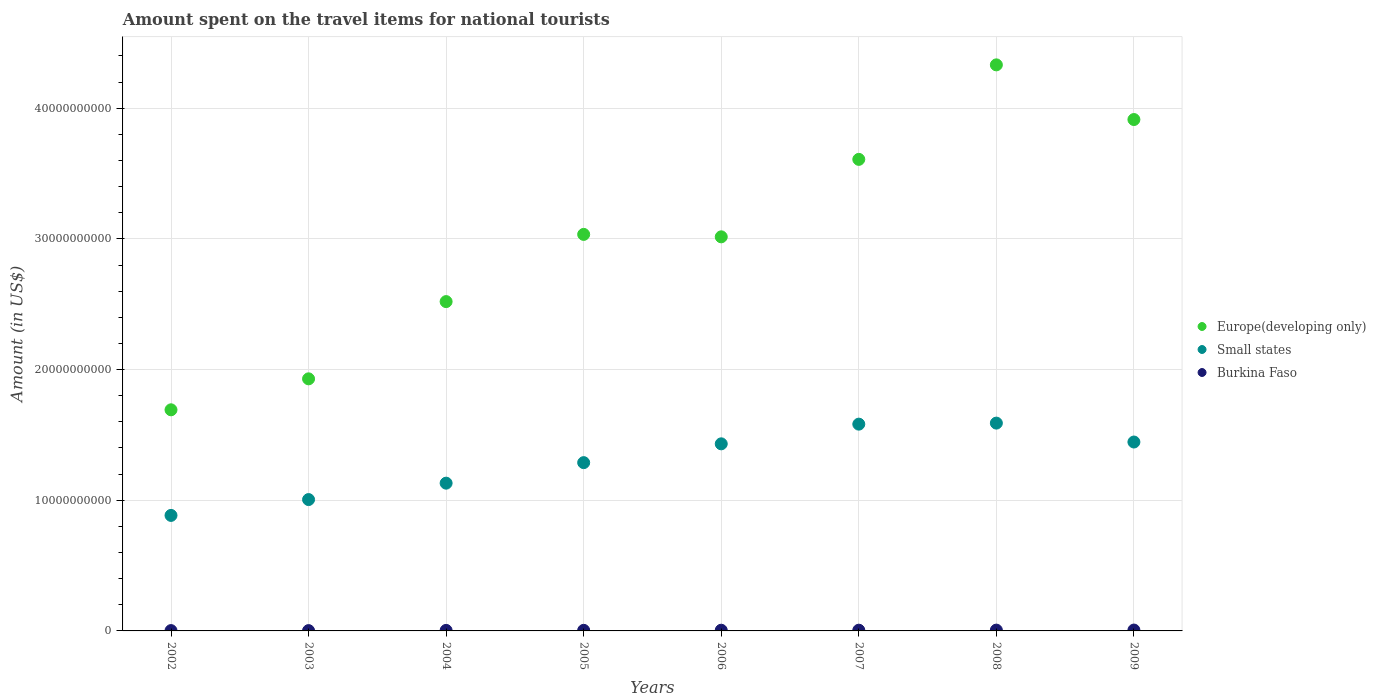How many different coloured dotlines are there?
Your answer should be compact. 3. Is the number of dotlines equal to the number of legend labels?
Offer a terse response. Yes. What is the amount spent on the travel items for national tourists in Europe(developing only) in 2003?
Provide a short and direct response. 1.93e+1. Across all years, what is the maximum amount spent on the travel items for national tourists in Burkina Faso?
Make the answer very short. 6.60e+07. Across all years, what is the minimum amount spent on the travel items for national tourists in Burkina Faso?
Give a very brief answer. 2.40e+07. What is the total amount spent on the travel items for national tourists in Europe(developing only) in the graph?
Your answer should be compact. 2.40e+11. What is the difference between the amount spent on the travel items for national tourists in Burkina Faso in 2006 and that in 2008?
Make the answer very short. -9.00e+06. What is the difference between the amount spent on the travel items for national tourists in Burkina Faso in 2007 and the amount spent on the travel items for national tourists in Europe(developing only) in 2009?
Your response must be concise. -3.91e+1. What is the average amount spent on the travel items for national tourists in Burkina Faso per year?
Keep it short and to the point. 4.64e+07. In the year 2005, what is the difference between the amount spent on the travel items for national tourists in Small states and amount spent on the travel items for national tourists in Burkina Faso?
Make the answer very short. 1.28e+1. What is the ratio of the amount spent on the travel items for national tourists in Burkina Faso in 2005 to that in 2007?
Ensure brevity in your answer.  0.8. Is the amount spent on the travel items for national tourists in Europe(developing only) in 2003 less than that in 2005?
Offer a very short reply. Yes. What is the difference between the highest and the second highest amount spent on the travel items for national tourists in Europe(developing only)?
Make the answer very short. 4.18e+09. What is the difference between the highest and the lowest amount spent on the travel items for national tourists in Small states?
Make the answer very short. 7.06e+09. Is it the case that in every year, the sum of the amount spent on the travel items for national tourists in Small states and amount spent on the travel items for national tourists in Europe(developing only)  is greater than the amount spent on the travel items for national tourists in Burkina Faso?
Ensure brevity in your answer.  Yes. Is the amount spent on the travel items for national tourists in Europe(developing only) strictly greater than the amount spent on the travel items for national tourists in Small states over the years?
Offer a very short reply. Yes. Is the amount spent on the travel items for national tourists in Small states strictly less than the amount spent on the travel items for national tourists in Burkina Faso over the years?
Your response must be concise. No. How many dotlines are there?
Keep it short and to the point. 3. How many years are there in the graph?
Your answer should be very brief. 8. Are the values on the major ticks of Y-axis written in scientific E-notation?
Give a very brief answer. No. Does the graph contain any zero values?
Make the answer very short. No. What is the title of the graph?
Provide a succinct answer. Amount spent on the travel items for national tourists. Does "Tanzania" appear as one of the legend labels in the graph?
Your answer should be compact. No. What is the Amount (in US$) of Europe(developing only) in 2002?
Offer a very short reply. 1.69e+1. What is the Amount (in US$) in Small states in 2002?
Your response must be concise. 8.84e+09. What is the Amount (in US$) of Burkina Faso in 2002?
Provide a short and direct response. 2.50e+07. What is the Amount (in US$) of Europe(developing only) in 2003?
Keep it short and to the point. 1.93e+1. What is the Amount (in US$) of Small states in 2003?
Offer a terse response. 1.01e+1. What is the Amount (in US$) of Burkina Faso in 2003?
Offer a very short reply. 2.40e+07. What is the Amount (in US$) of Europe(developing only) in 2004?
Your answer should be very brief. 2.52e+1. What is the Amount (in US$) of Small states in 2004?
Ensure brevity in your answer.  1.13e+1. What is the Amount (in US$) of Burkina Faso in 2004?
Your answer should be very brief. 4.00e+07. What is the Amount (in US$) of Europe(developing only) in 2005?
Give a very brief answer. 3.03e+1. What is the Amount (in US$) of Small states in 2005?
Your response must be concise. 1.29e+1. What is the Amount (in US$) in Burkina Faso in 2005?
Your answer should be compact. 4.50e+07. What is the Amount (in US$) of Europe(developing only) in 2006?
Your answer should be very brief. 3.02e+1. What is the Amount (in US$) in Small states in 2006?
Your response must be concise. 1.43e+1. What is the Amount (in US$) of Burkina Faso in 2006?
Keep it short and to the point. 5.30e+07. What is the Amount (in US$) in Europe(developing only) in 2007?
Your answer should be compact. 3.61e+1. What is the Amount (in US$) in Small states in 2007?
Make the answer very short. 1.58e+1. What is the Amount (in US$) in Burkina Faso in 2007?
Provide a succinct answer. 5.60e+07. What is the Amount (in US$) in Europe(developing only) in 2008?
Your answer should be very brief. 4.33e+1. What is the Amount (in US$) of Small states in 2008?
Your answer should be compact. 1.59e+1. What is the Amount (in US$) of Burkina Faso in 2008?
Ensure brevity in your answer.  6.20e+07. What is the Amount (in US$) of Europe(developing only) in 2009?
Make the answer very short. 3.91e+1. What is the Amount (in US$) in Small states in 2009?
Provide a short and direct response. 1.45e+1. What is the Amount (in US$) of Burkina Faso in 2009?
Give a very brief answer. 6.60e+07. Across all years, what is the maximum Amount (in US$) in Europe(developing only)?
Offer a very short reply. 4.33e+1. Across all years, what is the maximum Amount (in US$) of Small states?
Keep it short and to the point. 1.59e+1. Across all years, what is the maximum Amount (in US$) in Burkina Faso?
Offer a very short reply. 6.60e+07. Across all years, what is the minimum Amount (in US$) of Europe(developing only)?
Ensure brevity in your answer.  1.69e+1. Across all years, what is the minimum Amount (in US$) of Small states?
Offer a terse response. 8.84e+09. Across all years, what is the minimum Amount (in US$) of Burkina Faso?
Give a very brief answer. 2.40e+07. What is the total Amount (in US$) of Europe(developing only) in the graph?
Your answer should be compact. 2.40e+11. What is the total Amount (in US$) of Small states in the graph?
Your answer should be compact. 1.04e+11. What is the total Amount (in US$) of Burkina Faso in the graph?
Your answer should be compact. 3.71e+08. What is the difference between the Amount (in US$) in Europe(developing only) in 2002 and that in 2003?
Keep it short and to the point. -2.37e+09. What is the difference between the Amount (in US$) of Small states in 2002 and that in 2003?
Provide a succinct answer. -1.21e+09. What is the difference between the Amount (in US$) in Burkina Faso in 2002 and that in 2003?
Offer a very short reply. 1.00e+06. What is the difference between the Amount (in US$) in Europe(developing only) in 2002 and that in 2004?
Your response must be concise. -8.28e+09. What is the difference between the Amount (in US$) of Small states in 2002 and that in 2004?
Ensure brevity in your answer.  -2.47e+09. What is the difference between the Amount (in US$) in Burkina Faso in 2002 and that in 2004?
Make the answer very short. -1.50e+07. What is the difference between the Amount (in US$) in Europe(developing only) in 2002 and that in 2005?
Your answer should be very brief. -1.34e+1. What is the difference between the Amount (in US$) of Small states in 2002 and that in 2005?
Keep it short and to the point. -4.04e+09. What is the difference between the Amount (in US$) of Burkina Faso in 2002 and that in 2005?
Ensure brevity in your answer.  -2.00e+07. What is the difference between the Amount (in US$) in Europe(developing only) in 2002 and that in 2006?
Ensure brevity in your answer.  -1.32e+1. What is the difference between the Amount (in US$) of Small states in 2002 and that in 2006?
Your answer should be very brief. -5.48e+09. What is the difference between the Amount (in US$) of Burkina Faso in 2002 and that in 2006?
Make the answer very short. -2.80e+07. What is the difference between the Amount (in US$) in Europe(developing only) in 2002 and that in 2007?
Give a very brief answer. -1.92e+1. What is the difference between the Amount (in US$) in Small states in 2002 and that in 2007?
Your answer should be compact. -6.98e+09. What is the difference between the Amount (in US$) in Burkina Faso in 2002 and that in 2007?
Ensure brevity in your answer.  -3.10e+07. What is the difference between the Amount (in US$) in Europe(developing only) in 2002 and that in 2008?
Your response must be concise. -2.64e+1. What is the difference between the Amount (in US$) in Small states in 2002 and that in 2008?
Keep it short and to the point. -7.06e+09. What is the difference between the Amount (in US$) in Burkina Faso in 2002 and that in 2008?
Provide a succinct answer. -3.70e+07. What is the difference between the Amount (in US$) of Europe(developing only) in 2002 and that in 2009?
Offer a terse response. -2.22e+1. What is the difference between the Amount (in US$) of Small states in 2002 and that in 2009?
Provide a succinct answer. -5.62e+09. What is the difference between the Amount (in US$) in Burkina Faso in 2002 and that in 2009?
Your answer should be very brief. -4.10e+07. What is the difference between the Amount (in US$) in Europe(developing only) in 2003 and that in 2004?
Offer a terse response. -5.91e+09. What is the difference between the Amount (in US$) in Small states in 2003 and that in 2004?
Ensure brevity in your answer.  -1.26e+09. What is the difference between the Amount (in US$) of Burkina Faso in 2003 and that in 2004?
Keep it short and to the point. -1.60e+07. What is the difference between the Amount (in US$) in Europe(developing only) in 2003 and that in 2005?
Provide a short and direct response. -1.11e+1. What is the difference between the Amount (in US$) in Small states in 2003 and that in 2005?
Ensure brevity in your answer.  -2.83e+09. What is the difference between the Amount (in US$) of Burkina Faso in 2003 and that in 2005?
Offer a terse response. -2.10e+07. What is the difference between the Amount (in US$) in Europe(developing only) in 2003 and that in 2006?
Provide a short and direct response. -1.09e+1. What is the difference between the Amount (in US$) of Small states in 2003 and that in 2006?
Keep it short and to the point. -4.26e+09. What is the difference between the Amount (in US$) in Burkina Faso in 2003 and that in 2006?
Give a very brief answer. -2.90e+07. What is the difference between the Amount (in US$) in Europe(developing only) in 2003 and that in 2007?
Give a very brief answer. -1.68e+1. What is the difference between the Amount (in US$) in Small states in 2003 and that in 2007?
Offer a terse response. -5.77e+09. What is the difference between the Amount (in US$) of Burkina Faso in 2003 and that in 2007?
Ensure brevity in your answer.  -3.20e+07. What is the difference between the Amount (in US$) in Europe(developing only) in 2003 and that in 2008?
Your answer should be very brief. -2.40e+1. What is the difference between the Amount (in US$) of Small states in 2003 and that in 2008?
Your response must be concise. -5.85e+09. What is the difference between the Amount (in US$) in Burkina Faso in 2003 and that in 2008?
Provide a succinct answer. -3.80e+07. What is the difference between the Amount (in US$) in Europe(developing only) in 2003 and that in 2009?
Offer a very short reply. -1.98e+1. What is the difference between the Amount (in US$) of Small states in 2003 and that in 2009?
Offer a terse response. -4.40e+09. What is the difference between the Amount (in US$) in Burkina Faso in 2003 and that in 2009?
Provide a short and direct response. -4.20e+07. What is the difference between the Amount (in US$) in Europe(developing only) in 2004 and that in 2005?
Offer a terse response. -5.14e+09. What is the difference between the Amount (in US$) of Small states in 2004 and that in 2005?
Provide a short and direct response. -1.57e+09. What is the difference between the Amount (in US$) in Burkina Faso in 2004 and that in 2005?
Offer a very short reply. -5.00e+06. What is the difference between the Amount (in US$) in Europe(developing only) in 2004 and that in 2006?
Your answer should be compact. -4.96e+09. What is the difference between the Amount (in US$) of Small states in 2004 and that in 2006?
Provide a short and direct response. -3.01e+09. What is the difference between the Amount (in US$) of Burkina Faso in 2004 and that in 2006?
Provide a succinct answer. -1.30e+07. What is the difference between the Amount (in US$) in Europe(developing only) in 2004 and that in 2007?
Ensure brevity in your answer.  -1.09e+1. What is the difference between the Amount (in US$) in Small states in 2004 and that in 2007?
Offer a terse response. -4.52e+09. What is the difference between the Amount (in US$) of Burkina Faso in 2004 and that in 2007?
Offer a very short reply. -1.60e+07. What is the difference between the Amount (in US$) in Europe(developing only) in 2004 and that in 2008?
Your response must be concise. -1.81e+1. What is the difference between the Amount (in US$) of Small states in 2004 and that in 2008?
Your response must be concise. -4.60e+09. What is the difference between the Amount (in US$) in Burkina Faso in 2004 and that in 2008?
Ensure brevity in your answer.  -2.20e+07. What is the difference between the Amount (in US$) of Europe(developing only) in 2004 and that in 2009?
Your response must be concise. -1.39e+1. What is the difference between the Amount (in US$) of Small states in 2004 and that in 2009?
Your answer should be compact. -3.15e+09. What is the difference between the Amount (in US$) in Burkina Faso in 2004 and that in 2009?
Make the answer very short. -2.60e+07. What is the difference between the Amount (in US$) of Europe(developing only) in 2005 and that in 2006?
Provide a short and direct response. 1.86e+08. What is the difference between the Amount (in US$) of Small states in 2005 and that in 2006?
Your answer should be compact. -1.44e+09. What is the difference between the Amount (in US$) of Burkina Faso in 2005 and that in 2006?
Keep it short and to the point. -8.00e+06. What is the difference between the Amount (in US$) in Europe(developing only) in 2005 and that in 2007?
Offer a very short reply. -5.74e+09. What is the difference between the Amount (in US$) of Small states in 2005 and that in 2007?
Provide a succinct answer. -2.95e+09. What is the difference between the Amount (in US$) of Burkina Faso in 2005 and that in 2007?
Your answer should be very brief. -1.10e+07. What is the difference between the Amount (in US$) of Europe(developing only) in 2005 and that in 2008?
Your answer should be compact. -1.30e+1. What is the difference between the Amount (in US$) of Small states in 2005 and that in 2008?
Your response must be concise. -3.02e+09. What is the difference between the Amount (in US$) in Burkina Faso in 2005 and that in 2008?
Provide a short and direct response. -1.70e+07. What is the difference between the Amount (in US$) in Europe(developing only) in 2005 and that in 2009?
Offer a terse response. -8.79e+09. What is the difference between the Amount (in US$) of Small states in 2005 and that in 2009?
Ensure brevity in your answer.  -1.58e+09. What is the difference between the Amount (in US$) in Burkina Faso in 2005 and that in 2009?
Your answer should be very brief. -2.10e+07. What is the difference between the Amount (in US$) in Europe(developing only) in 2006 and that in 2007?
Provide a short and direct response. -5.93e+09. What is the difference between the Amount (in US$) of Small states in 2006 and that in 2007?
Your answer should be very brief. -1.51e+09. What is the difference between the Amount (in US$) in Europe(developing only) in 2006 and that in 2008?
Provide a short and direct response. -1.32e+1. What is the difference between the Amount (in US$) in Small states in 2006 and that in 2008?
Keep it short and to the point. -1.59e+09. What is the difference between the Amount (in US$) in Burkina Faso in 2006 and that in 2008?
Offer a terse response. -9.00e+06. What is the difference between the Amount (in US$) in Europe(developing only) in 2006 and that in 2009?
Provide a short and direct response. -8.98e+09. What is the difference between the Amount (in US$) in Small states in 2006 and that in 2009?
Ensure brevity in your answer.  -1.39e+08. What is the difference between the Amount (in US$) in Burkina Faso in 2006 and that in 2009?
Provide a short and direct response. -1.30e+07. What is the difference between the Amount (in US$) in Europe(developing only) in 2007 and that in 2008?
Provide a succinct answer. -7.23e+09. What is the difference between the Amount (in US$) in Small states in 2007 and that in 2008?
Provide a succinct answer. -7.92e+07. What is the difference between the Amount (in US$) in Burkina Faso in 2007 and that in 2008?
Your answer should be compact. -6.00e+06. What is the difference between the Amount (in US$) of Europe(developing only) in 2007 and that in 2009?
Provide a short and direct response. -3.05e+09. What is the difference between the Amount (in US$) in Small states in 2007 and that in 2009?
Your response must be concise. 1.37e+09. What is the difference between the Amount (in US$) in Burkina Faso in 2007 and that in 2009?
Make the answer very short. -1.00e+07. What is the difference between the Amount (in US$) in Europe(developing only) in 2008 and that in 2009?
Your answer should be compact. 4.18e+09. What is the difference between the Amount (in US$) in Small states in 2008 and that in 2009?
Your answer should be compact. 1.45e+09. What is the difference between the Amount (in US$) in Europe(developing only) in 2002 and the Amount (in US$) in Small states in 2003?
Give a very brief answer. 6.87e+09. What is the difference between the Amount (in US$) in Europe(developing only) in 2002 and the Amount (in US$) in Burkina Faso in 2003?
Make the answer very short. 1.69e+1. What is the difference between the Amount (in US$) of Small states in 2002 and the Amount (in US$) of Burkina Faso in 2003?
Your answer should be very brief. 8.82e+09. What is the difference between the Amount (in US$) of Europe(developing only) in 2002 and the Amount (in US$) of Small states in 2004?
Make the answer very short. 5.61e+09. What is the difference between the Amount (in US$) in Europe(developing only) in 2002 and the Amount (in US$) in Burkina Faso in 2004?
Provide a succinct answer. 1.69e+1. What is the difference between the Amount (in US$) of Small states in 2002 and the Amount (in US$) of Burkina Faso in 2004?
Offer a very short reply. 8.80e+09. What is the difference between the Amount (in US$) in Europe(developing only) in 2002 and the Amount (in US$) in Small states in 2005?
Your response must be concise. 4.04e+09. What is the difference between the Amount (in US$) in Europe(developing only) in 2002 and the Amount (in US$) in Burkina Faso in 2005?
Your answer should be compact. 1.69e+1. What is the difference between the Amount (in US$) in Small states in 2002 and the Amount (in US$) in Burkina Faso in 2005?
Give a very brief answer. 8.79e+09. What is the difference between the Amount (in US$) in Europe(developing only) in 2002 and the Amount (in US$) in Small states in 2006?
Keep it short and to the point. 2.60e+09. What is the difference between the Amount (in US$) of Europe(developing only) in 2002 and the Amount (in US$) of Burkina Faso in 2006?
Your response must be concise. 1.69e+1. What is the difference between the Amount (in US$) in Small states in 2002 and the Amount (in US$) in Burkina Faso in 2006?
Provide a succinct answer. 8.79e+09. What is the difference between the Amount (in US$) in Europe(developing only) in 2002 and the Amount (in US$) in Small states in 2007?
Give a very brief answer. 1.10e+09. What is the difference between the Amount (in US$) of Europe(developing only) in 2002 and the Amount (in US$) of Burkina Faso in 2007?
Keep it short and to the point. 1.69e+1. What is the difference between the Amount (in US$) of Small states in 2002 and the Amount (in US$) of Burkina Faso in 2007?
Your response must be concise. 8.78e+09. What is the difference between the Amount (in US$) in Europe(developing only) in 2002 and the Amount (in US$) in Small states in 2008?
Offer a terse response. 1.02e+09. What is the difference between the Amount (in US$) of Europe(developing only) in 2002 and the Amount (in US$) of Burkina Faso in 2008?
Offer a very short reply. 1.69e+1. What is the difference between the Amount (in US$) of Small states in 2002 and the Amount (in US$) of Burkina Faso in 2008?
Offer a very short reply. 8.78e+09. What is the difference between the Amount (in US$) of Europe(developing only) in 2002 and the Amount (in US$) of Small states in 2009?
Keep it short and to the point. 2.46e+09. What is the difference between the Amount (in US$) in Europe(developing only) in 2002 and the Amount (in US$) in Burkina Faso in 2009?
Ensure brevity in your answer.  1.69e+1. What is the difference between the Amount (in US$) in Small states in 2002 and the Amount (in US$) in Burkina Faso in 2009?
Ensure brevity in your answer.  8.77e+09. What is the difference between the Amount (in US$) of Europe(developing only) in 2003 and the Amount (in US$) of Small states in 2004?
Keep it short and to the point. 7.98e+09. What is the difference between the Amount (in US$) in Europe(developing only) in 2003 and the Amount (in US$) in Burkina Faso in 2004?
Your answer should be compact. 1.92e+1. What is the difference between the Amount (in US$) of Small states in 2003 and the Amount (in US$) of Burkina Faso in 2004?
Keep it short and to the point. 1.00e+1. What is the difference between the Amount (in US$) of Europe(developing only) in 2003 and the Amount (in US$) of Small states in 2005?
Make the answer very short. 6.41e+09. What is the difference between the Amount (in US$) in Europe(developing only) in 2003 and the Amount (in US$) in Burkina Faso in 2005?
Your answer should be compact. 1.92e+1. What is the difference between the Amount (in US$) of Small states in 2003 and the Amount (in US$) of Burkina Faso in 2005?
Provide a succinct answer. 1.00e+1. What is the difference between the Amount (in US$) of Europe(developing only) in 2003 and the Amount (in US$) of Small states in 2006?
Ensure brevity in your answer.  4.97e+09. What is the difference between the Amount (in US$) in Europe(developing only) in 2003 and the Amount (in US$) in Burkina Faso in 2006?
Provide a succinct answer. 1.92e+1. What is the difference between the Amount (in US$) in Small states in 2003 and the Amount (in US$) in Burkina Faso in 2006?
Ensure brevity in your answer.  1.00e+1. What is the difference between the Amount (in US$) of Europe(developing only) in 2003 and the Amount (in US$) of Small states in 2007?
Your answer should be compact. 3.47e+09. What is the difference between the Amount (in US$) in Europe(developing only) in 2003 and the Amount (in US$) in Burkina Faso in 2007?
Provide a short and direct response. 1.92e+1. What is the difference between the Amount (in US$) in Small states in 2003 and the Amount (in US$) in Burkina Faso in 2007?
Provide a succinct answer. 1.00e+1. What is the difference between the Amount (in US$) of Europe(developing only) in 2003 and the Amount (in US$) of Small states in 2008?
Keep it short and to the point. 3.39e+09. What is the difference between the Amount (in US$) of Europe(developing only) in 2003 and the Amount (in US$) of Burkina Faso in 2008?
Provide a succinct answer. 1.92e+1. What is the difference between the Amount (in US$) of Small states in 2003 and the Amount (in US$) of Burkina Faso in 2008?
Give a very brief answer. 9.99e+09. What is the difference between the Amount (in US$) in Europe(developing only) in 2003 and the Amount (in US$) in Small states in 2009?
Your answer should be compact. 4.83e+09. What is the difference between the Amount (in US$) in Europe(developing only) in 2003 and the Amount (in US$) in Burkina Faso in 2009?
Provide a succinct answer. 1.92e+1. What is the difference between the Amount (in US$) of Small states in 2003 and the Amount (in US$) of Burkina Faso in 2009?
Offer a terse response. 9.99e+09. What is the difference between the Amount (in US$) of Europe(developing only) in 2004 and the Amount (in US$) of Small states in 2005?
Offer a very short reply. 1.23e+1. What is the difference between the Amount (in US$) of Europe(developing only) in 2004 and the Amount (in US$) of Burkina Faso in 2005?
Provide a short and direct response. 2.52e+1. What is the difference between the Amount (in US$) of Small states in 2004 and the Amount (in US$) of Burkina Faso in 2005?
Offer a very short reply. 1.13e+1. What is the difference between the Amount (in US$) in Europe(developing only) in 2004 and the Amount (in US$) in Small states in 2006?
Your answer should be very brief. 1.09e+1. What is the difference between the Amount (in US$) in Europe(developing only) in 2004 and the Amount (in US$) in Burkina Faso in 2006?
Offer a terse response. 2.51e+1. What is the difference between the Amount (in US$) of Small states in 2004 and the Amount (in US$) of Burkina Faso in 2006?
Make the answer very short. 1.13e+1. What is the difference between the Amount (in US$) in Europe(developing only) in 2004 and the Amount (in US$) in Small states in 2007?
Your answer should be very brief. 9.38e+09. What is the difference between the Amount (in US$) of Europe(developing only) in 2004 and the Amount (in US$) of Burkina Faso in 2007?
Provide a short and direct response. 2.51e+1. What is the difference between the Amount (in US$) of Small states in 2004 and the Amount (in US$) of Burkina Faso in 2007?
Provide a short and direct response. 1.13e+1. What is the difference between the Amount (in US$) in Europe(developing only) in 2004 and the Amount (in US$) in Small states in 2008?
Your response must be concise. 9.30e+09. What is the difference between the Amount (in US$) of Europe(developing only) in 2004 and the Amount (in US$) of Burkina Faso in 2008?
Ensure brevity in your answer.  2.51e+1. What is the difference between the Amount (in US$) in Small states in 2004 and the Amount (in US$) in Burkina Faso in 2008?
Provide a short and direct response. 1.12e+1. What is the difference between the Amount (in US$) of Europe(developing only) in 2004 and the Amount (in US$) of Small states in 2009?
Provide a short and direct response. 1.07e+1. What is the difference between the Amount (in US$) in Europe(developing only) in 2004 and the Amount (in US$) in Burkina Faso in 2009?
Your answer should be very brief. 2.51e+1. What is the difference between the Amount (in US$) of Small states in 2004 and the Amount (in US$) of Burkina Faso in 2009?
Provide a succinct answer. 1.12e+1. What is the difference between the Amount (in US$) of Europe(developing only) in 2005 and the Amount (in US$) of Small states in 2006?
Offer a terse response. 1.60e+1. What is the difference between the Amount (in US$) in Europe(developing only) in 2005 and the Amount (in US$) in Burkina Faso in 2006?
Offer a very short reply. 3.03e+1. What is the difference between the Amount (in US$) of Small states in 2005 and the Amount (in US$) of Burkina Faso in 2006?
Offer a terse response. 1.28e+1. What is the difference between the Amount (in US$) of Europe(developing only) in 2005 and the Amount (in US$) of Small states in 2007?
Provide a short and direct response. 1.45e+1. What is the difference between the Amount (in US$) of Europe(developing only) in 2005 and the Amount (in US$) of Burkina Faso in 2007?
Make the answer very short. 3.03e+1. What is the difference between the Amount (in US$) in Small states in 2005 and the Amount (in US$) in Burkina Faso in 2007?
Keep it short and to the point. 1.28e+1. What is the difference between the Amount (in US$) of Europe(developing only) in 2005 and the Amount (in US$) of Small states in 2008?
Ensure brevity in your answer.  1.44e+1. What is the difference between the Amount (in US$) in Europe(developing only) in 2005 and the Amount (in US$) in Burkina Faso in 2008?
Ensure brevity in your answer.  3.03e+1. What is the difference between the Amount (in US$) of Small states in 2005 and the Amount (in US$) of Burkina Faso in 2008?
Offer a very short reply. 1.28e+1. What is the difference between the Amount (in US$) in Europe(developing only) in 2005 and the Amount (in US$) in Small states in 2009?
Make the answer very short. 1.59e+1. What is the difference between the Amount (in US$) of Europe(developing only) in 2005 and the Amount (in US$) of Burkina Faso in 2009?
Offer a terse response. 3.03e+1. What is the difference between the Amount (in US$) in Small states in 2005 and the Amount (in US$) in Burkina Faso in 2009?
Give a very brief answer. 1.28e+1. What is the difference between the Amount (in US$) in Europe(developing only) in 2006 and the Amount (in US$) in Small states in 2007?
Provide a short and direct response. 1.43e+1. What is the difference between the Amount (in US$) of Europe(developing only) in 2006 and the Amount (in US$) of Burkina Faso in 2007?
Provide a succinct answer. 3.01e+1. What is the difference between the Amount (in US$) of Small states in 2006 and the Amount (in US$) of Burkina Faso in 2007?
Provide a succinct answer. 1.43e+1. What is the difference between the Amount (in US$) in Europe(developing only) in 2006 and the Amount (in US$) in Small states in 2008?
Your answer should be compact. 1.43e+1. What is the difference between the Amount (in US$) in Europe(developing only) in 2006 and the Amount (in US$) in Burkina Faso in 2008?
Make the answer very short. 3.01e+1. What is the difference between the Amount (in US$) of Small states in 2006 and the Amount (in US$) of Burkina Faso in 2008?
Offer a terse response. 1.43e+1. What is the difference between the Amount (in US$) in Europe(developing only) in 2006 and the Amount (in US$) in Small states in 2009?
Offer a terse response. 1.57e+1. What is the difference between the Amount (in US$) of Europe(developing only) in 2006 and the Amount (in US$) of Burkina Faso in 2009?
Provide a succinct answer. 3.01e+1. What is the difference between the Amount (in US$) of Small states in 2006 and the Amount (in US$) of Burkina Faso in 2009?
Your answer should be very brief. 1.42e+1. What is the difference between the Amount (in US$) of Europe(developing only) in 2007 and the Amount (in US$) of Small states in 2008?
Give a very brief answer. 2.02e+1. What is the difference between the Amount (in US$) in Europe(developing only) in 2007 and the Amount (in US$) in Burkina Faso in 2008?
Make the answer very short. 3.60e+1. What is the difference between the Amount (in US$) of Small states in 2007 and the Amount (in US$) of Burkina Faso in 2008?
Ensure brevity in your answer.  1.58e+1. What is the difference between the Amount (in US$) in Europe(developing only) in 2007 and the Amount (in US$) in Small states in 2009?
Make the answer very short. 2.16e+1. What is the difference between the Amount (in US$) of Europe(developing only) in 2007 and the Amount (in US$) of Burkina Faso in 2009?
Provide a succinct answer. 3.60e+1. What is the difference between the Amount (in US$) in Small states in 2007 and the Amount (in US$) in Burkina Faso in 2009?
Keep it short and to the point. 1.58e+1. What is the difference between the Amount (in US$) in Europe(developing only) in 2008 and the Amount (in US$) in Small states in 2009?
Your answer should be compact. 2.89e+1. What is the difference between the Amount (in US$) in Europe(developing only) in 2008 and the Amount (in US$) in Burkina Faso in 2009?
Your response must be concise. 4.32e+1. What is the difference between the Amount (in US$) of Small states in 2008 and the Amount (in US$) of Burkina Faso in 2009?
Provide a short and direct response. 1.58e+1. What is the average Amount (in US$) of Europe(developing only) per year?
Make the answer very short. 3.01e+1. What is the average Amount (in US$) of Small states per year?
Provide a short and direct response. 1.29e+1. What is the average Amount (in US$) of Burkina Faso per year?
Make the answer very short. 4.64e+07. In the year 2002, what is the difference between the Amount (in US$) in Europe(developing only) and Amount (in US$) in Small states?
Your answer should be very brief. 8.08e+09. In the year 2002, what is the difference between the Amount (in US$) in Europe(developing only) and Amount (in US$) in Burkina Faso?
Keep it short and to the point. 1.69e+1. In the year 2002, what is the difference between the Amount (in US$) in Small states and Amount (in US$) in Burkina Faso?
Your answer should be very brief. 8.81e+09. In the year 2003, what is the difference between the Amount (in US$) in Europe(developing only) and Amount (in US$) in Small states?
Provide a short and direct response. 9.24e+09. In the year 2003, what is the difference between the Amount (in US$) of Europe(developing only) and Amount (in US$) of Burkina Faso?
Provide a succinct answer. 1.93e+1. In the year 2003, what is the difference between the Amount (in US$) in Small states and Amount (in US$) in Burkina Faso?
Provide a short and direct response. 1.00e+1. In the year 2004, what is the difference between the Amount (in US$) in Europe(developing only) and Amount (in US$) in Small states?
Keep it short and to the point. 1.39e+1. In the year 2004, what is the difference between the Amount (in US$) of Europe(developing only) and Amount (in US$) of Burkina Faso?
Provide a succinct answer. 2.52e+1. In the year 2004, what is the difference between the Amount (in US$) in Small states and Amount (in US$) in Burkina Faso?
Ensure brevity in your answer.  1.13e+1. In the year 2005, what is the difference between the Amount (in US$) of Europe(developing only) and Amount (in US$) of Small states?
Keep it short and to the point. 1.75e+1. In the year 2005, what is the difference between the Amount (in US$) in Europe(developing only) and Amount (in US$) in Burkina Faso?
Your answer should be compact. 3.03e+1. In the year 2005, what is the difference between the Amount (in US$) in Small states and Amount (in US$) in Burkina Faso?
Ensure brevity in your answer.  1.28e+1. In the year 2006, what is the difference between the Amount (in US$) of Europe(developing only) and Amount (in US$) of Small states?
Offer a terse response. 1.58e+1. In the year 2006, what is the difference between the Amount (in US$) in Europe(developing only) and Amount (in US$) in Burkina Faso?
Give a very brief answer. 3.01e+1. In the year 2006, what is the difference between the Amount (in US$) of Small states and Amount (in US$) of Burkina Faso?
Keep it short and to the point. 1.43e+1. In the year 2007, what is the difference between the Amount (in US$) in Europe(developing only) and Amount (in US$) in Small states?
Offer a terse response. 2.03e+1. In the year 2007, what is the difference between the Amount (in US$) in Europe(developing only) and Amount (in US$) in Burkina Faso?
Provide a short and direct response. 3.60e+1. In the year 2007, what is the difference between the Amount (in US$) in Small states and Amount (in US$) in Burkina Faso?
Your answer should be compact. 1.58e+1. In the year 2008, what is the difference between the Amount (in US$) in Europe(developing only) and Amount (in US$) in Small states?
Provide a short and direct response. 2.74e+1. In the year 2008, what is the difference between the Amount (in US$) of Europe(developing only) and Amount (in US$) of Burkina Faso?
Offer a very short reply. 4.33e+1. In the year 2008, what is the difference between the Amount (in US$) in Small states and Amount (in US$) in Burkina Faso?
Keep it short and to the point. 1.58e+1. In the year 2009, what is the difference between the Amount (in US$) in Europe(developing only) and Amount (in US$) in Small states?
Ensure brevity in your answer.  2.47e+1. In the year 2009, what is the difference between the Amount (in US$) of Europe(developing only) and Amount (in US$) of Burkina Faso?
Offer a terse response. 3.91e+1. In the year 2009, what is the difference between the Amount (in US$) of Small states and Amount (in US$) of Burkina Faso?
Your answer should be very brief. 1.44e+1. What is the ratio of the Amount (in US$) in Europe(developing only) in 2002 to that in 2003?
Offer a very short reply. 0.88. What is the ratio of the Amount (in US$) of Small states in 2002 to that in 2003?
Offer a terse response. 0.88. What is the ratio of the Amount (in US$) in Burkina Faso in 2002 to that in 2003?
Your response must be concise. 1.04. What is the ratio of the Amount (in US$) of Europe(developing only) in 2002 to that in 2004?
Keep it short and to the point. 0.67. What is the ratio of the Amount (in US$) of Small states in 2002 to that in 2004?
Your answer should be compact. 0.78. What is the ratio of the Amount (in US$) in Burkina Faso in 2002 to that in 2004?
Provide a short and direct response. 0.62. What is the ratio of the Amount (in US$) of Europe(developing only) in 2002 to that in 2005?
Your answer should be compact. 0.56. What is the ratio of the Amount (in US$) of Small states in 2002 to that in 2005?
Give a very brief answer. 0.69. What is the ratio of the Amount (in US$) in Burkina Faso in 2002 to that in 2005?
Make the answer very short. 0.56. What is the ratio of the Amount (in US$) of Europe(developing only) in 2002 to that in 2006?
Your answer should be very brief. 0.56. What is the ratio of the Amount (in US$) in Small states in 2002 to that in 2006?
Give a very brief answer. 0.62. What is the ratio of the Amount (in US$) of Burkina Faso in 2002 to that in 2006?
Make the answer very short. 0.47. What is the ratio of the Amount (in US$) of Europe(developing only) in 2002 to that in 2007?
Provide a short and direct response. 0.47. What is the ratio of the Amount (in US$) of Small states in 2002 to that in 2007?
Ensure brevity in your answer.  0.56. What is the ratio of the Amount (in US$) in Burkina Faso in 2002 to that in 2007?
Offer a terse response. 0.45. What is the ratio of the Amount (in US$) of Europe(developing only) in 2002 to that in 2008?
Offer a terse response. 0.39. What is the ratio of the Amount (in US$) in Small states in 2002 to that in 2008?
Provide a succinct answer. 0.56. What is the ratio of the Amount (in US$) of Burkina Faso in 2002 to that in 2008?
Keep it short and to the point. 0.4. What is the ratio of the Amount (in US$) in Europe(developing only) in 2002 to that in 2009?
Provide a short and direct response. 0.43. What is the ratio of the Amount (in US$) of Small states in 2002 to that in 2009?
Keep it short and to the point. 0.61. What is the ratio of the Amount (in US$) of Burkina Faso in 2002 to that in 2009?
Provide a succinct answer. 0.38. What is the ratio of the Amount (in US$) of Europe(developing only) in 2003 to that in 2004?
Provide a short and direct response. 0.77. What is the ratio of the Amount (in US$) of Burkina Faso in 2003 to that in 2004?
Provide a short and direct response. 0.6. What is the ratio of the Amount (in US$) of Europe(developing only) in 2003 to that in 2005?
Give a very brief answer. 0.64. What is the ratio of the Amount (in US$) in Small states in 2003 to that in 2005?
Your answer should be very brief. 0.78. What is the ratio of the Amount (in US$) of Burkina Faso in 2003 to that in 2005?
Your answer should be very brief. 0.53. What is the ratio of the Amount (in US$) of Europe(developing only) in 2003 to that in 2006?
Offer a very short reply. 0.64. What is the ratio of the Amount (in US$) of Small states in 2003 to that in 2006?
Provide a succinct answer. 0.7. What is the ratio of the Amount (in US$) of Burkina Faso in 2003 to that in 2006?
Make the answer very short. 0.45. What is the ratio of the Amount (in US$) in Europe(developing only) in 2003 to that in 2007?
Make the answer very short. 0.53. What is the ratio of the Amount (in US$) of Small states in 2003 to that in 2007?
Your response must be concise. 0.64. What is the ratio of the Amount (in US$) in Burkina Faso in 2003 to that in 2007?
Your response must be concise. 0.43. What is the ratio of the Amount (in US$) in Europe(developing only) in 2003 to that in 2008?
Provide a short and direct response. 0.45. What is the ratio of the Amount (in US$) in Small states in 2003 to that in 2008?
Make the answer very short. 0.63. What is the ratio of the Amount (in US$) of Burkina Faso in 2003 to that in 2008?
Ensure brevity in your answer.  0.39. What is the ratio of the Amount (in US$) in Europe(developing only) in 2003 to that in 2009?
Keep it short and to the point. 0.49. What is the ratio of the Amount (in US$) of Small states in 2003 to that in 2009?
Offer a very short reply. 0.7. What is the ratio of the Amount (in US$) in Burkina Faso in 2003 to that in 2009?
Offer a very short reply. 0.36. What is the ratio of the Amount (in US$) in Europe(developing only) in 2004 to that in 2005?
Your answer should be compact. 0.83. What is the ratio of the Amount (in US$) in Small states in 2004 to that in 2005?
Provide a short and direct response. 0.88. What is the ratio of the Amount (in US$) of Europe(developing only) in 2004 to that in 2006?
Offer a terse response. 0.84. What is the ratio of the Amount (in US$) of Small states in 2004 to that in 2006?
Keep it short and to the point. 0.79. What is the ratio of the Amount (in US$) in Burkina Faso in 2004 to that in 2006?
Offer a very short reply. 0.75. What is the ratio of the Amount (in US$) of Europe(developing only) in 2004 to that in 2007?
Provide a succinct answer. 0.7. What is the ratio of the Amount (in US$) of Small states in 2004 to that in 2007?
Offer a terse response. 0.71. What is the ratio of the Amount (in US$) of Europe(developing only) in 2004 to that in 2008?
Your answer should be compact. 0.58. What is the ratio of the Amount (in US$) in Small states in 2004 to that in 2008?
Ensure brevity in your answer.  0.71. What is the ratio of the Amount (in US$) in Burkina Faso in 2004 to that in 2008?
Offer a terse response. 0.65. What is the ratio of the Amount (in US$) of Europe(developing only) in 2004 to that in 2009?
Ensure brevity in your answer.  0.64. What is the ratio of the Amount (in US$) of Small states in 2004 to that in 2009?
Make the answer very short. 0.78. What is the ratio of the Amount (in US$) of Burkina Faso in 2004 to that in 2009?
Keep it short and to the point. 0.61. What is the ratio of the Amount (in US$) of Europe(developing only) in 2005 to that in 2006?
Your answer should be very brief. 1.01. What is the ratio of the Amount (in US$) of Small states in 2005 to that in 2006?
Provide a short and direct response. 0.9. What is the ratio of the Amount (in US$) of Burkina Faso in 2005 to that in 2006?
Offer a very short reply. 0.85. What is the ratio of the Amount (in US$) of Europe(developing only) in 2005 to that in 2007?
Ensure brevity in your answer.  0.84. What is the ratio of the Amount (in US$) in Small states in 2005 to that in 2007?
Provide a short and direct response. 0.81. What is the ratio of the Amount (in US$) of Burkina Faso in 2005 to that in 2007?
Ensure brevity in your answer.  0.8. What is the ratio of the Amount (in US$) in Europe(developing only) in 2005 to that in 2008?
Make the answer very short. 0.7. What is the ratio of the Amount (in US$) of Small states in 2005 to that in 2008?
Your answer should be very brief. 0.81. What is the ratio of the Amount (in US$) of Burkina Faso in 2005 to that in 2008?
Make the answer very short. 0.73. What is the ratio of the Amount (in US$) in Europe(developing only) in 2005 to that in 2009?
Give a very brief answer. 0.78. What is the ratio of the Amount (in US$) in Small states in 2005 to that in 2009?
Your answer should be compact. 0.89. What is the ratio of the Amount (in US$) of Burkina Faso in 2005 to that in 2009?
Give a very brief answer. 0.68. What is the ratio of the Amount (in US$) of Europe(developing only) in 2006 to that in 2007?
Provide a short and direct response. 0.84. What is the ratio of the Amount (in US$) of Small states in 2006 to that in 2007?
Your answer should be compact. 0.9. What is the ratio of the Amount (in US$) in Burkina Faso in 2006 to that in 2007?
Keep it short and to the point. 0.95. What is the ratio of the Amount (in US$) in Europe(developing only) in 2006 to that in 2008?
Give a very brief answer. 0.7. What is the ratio of the Amount (in US$) in Small states in 2006 to that in 2008?
Your answer should be very brief. 0.9. What is the ratio of the Amount (in US$) of Burkina Faso in 2006 to that in 2008?
Provide a short and direct response. 0.85. What is the ratio of the Amount (in US$) in Europe(developing only) in 2006 to that in 2009?
Make the answer very short. 0.77. What is the ratio of the Amount (in US$) of Small states in 2006 to that in 2009?
Ensure brevity in your answer.  0.99. What is the ratio of the Amount (in US$) of Burkina Faso in 2006 to that in 2009?
Provide a short and direct response. 0.8. What is the ratio of the Amount (in US$) in Europe(developing only) in 2007 to that in 2008?
Offer a very short reply. 0.83. What is the ratio of the Amount (in US$) in Burkina Faso in 2007 to that in 2008?
Your answer should be compact. 0.9. What is the ratio of the Amount (in US$) in Europe(developing only) in 2007 to that in 2009?
Provide a succinct answer. 0.92. What is the ratio of the Amount (in US$) of Small states in 2007 to that in 2009?
Offer a very short reply. 1.09. What is the ratio of the Amount (in US$) of Burkina Faso in 2007 to that in 2009?
Ensure brevity in your answer.  0.85. What is the ratio of the Amount (in US$) of Europe(developing only) in 2008 to that in 2009?
Your response must be concise. 1.11. What is the ratio of the Amount (in US$) of Small states in 2008 to that in 2009?
Provide a short and direct response. 1.1. What is the ratio of the Amount (in US$) of Burkina Faso in 2008 to that in 2009?
Your answer should be compact. 0.94. What is the difference between the highest and the second highest Amount (in US$) in Europe(developing only)?
Your answer should be very brief. 4.18e+09. What is the difference between the highest and the second highest Amount (in US$) in Small states?
Offer a terse response. 7.92e+07. What is the difference between the highest and the lowest Amount (in US$) in Europe(developing only)?
Provide a short and direct response. 2.64e+1. What is the difference between the highest and the lowest Amount (in US$) of Small states?
Make the answer very short. 7.06e+09. What is the difference between the highest and the lowest Amount (in US$) of Burkina Faso?
Keep it short and to the point. 4.20e+07. 